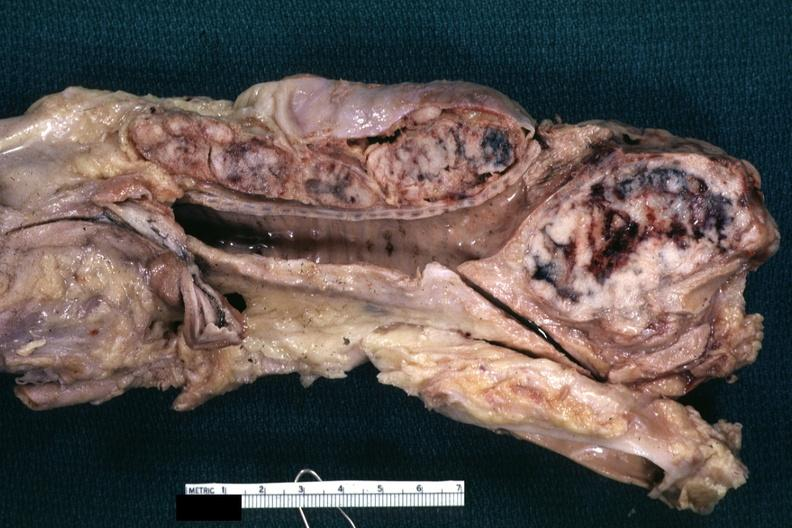what does this image show?
Answer the question using a single word or phrase. Fixed tissue frontal section through trachea showing grossly enlarged mediastinal nodes with necrosis and anthracotic pigment small cell carcinoma of lung 